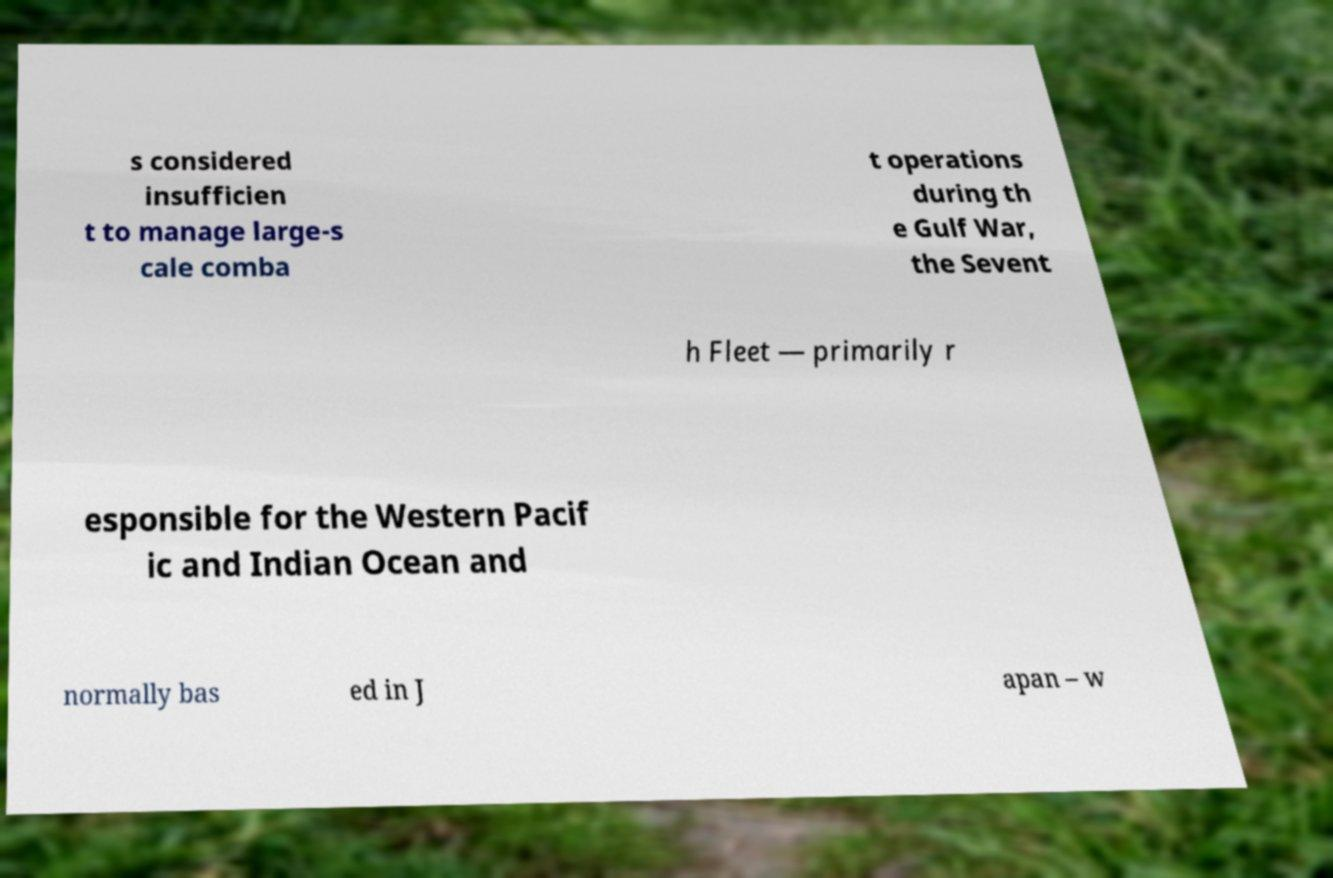There's text embedded in this image that I need extracted. Can you transcribe it verbatim? s considered insufficien t to manage large-s cale comba t operations during th e Gulf War, the Sevent h Fleet — primarily r esponsible for the Western Pacif ic and Indian Ocean and normally bas ed in J apan – w 